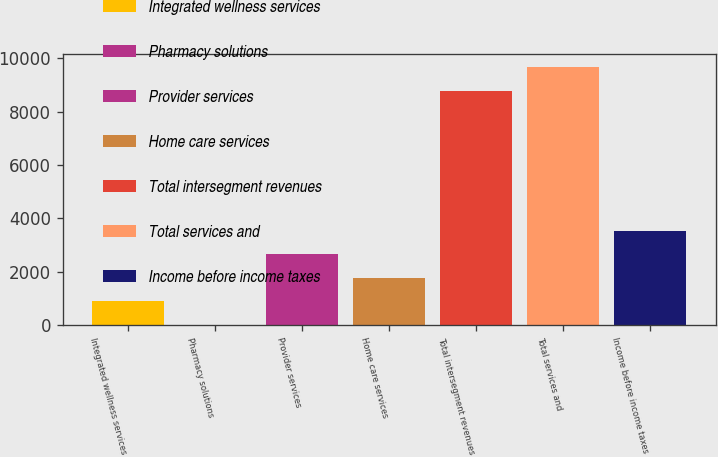Convert chart. <chart><loc_0><loc_0><loc_500><loc_500><bar_chart><fcel>Integrated wellness services<fcel>Pharmacy solutions<fcel>Provider services<fcel>Home care services<fcel>Total intersegment revenues<fcel>Total services and<fcel>Income before income taxes<nl><fcel>883.66<fcel>1.84<fcel>2647.3<fcel>1765.48<fcel>8786<fcel>9667.82<fcel>3529.12<nl></chart> 